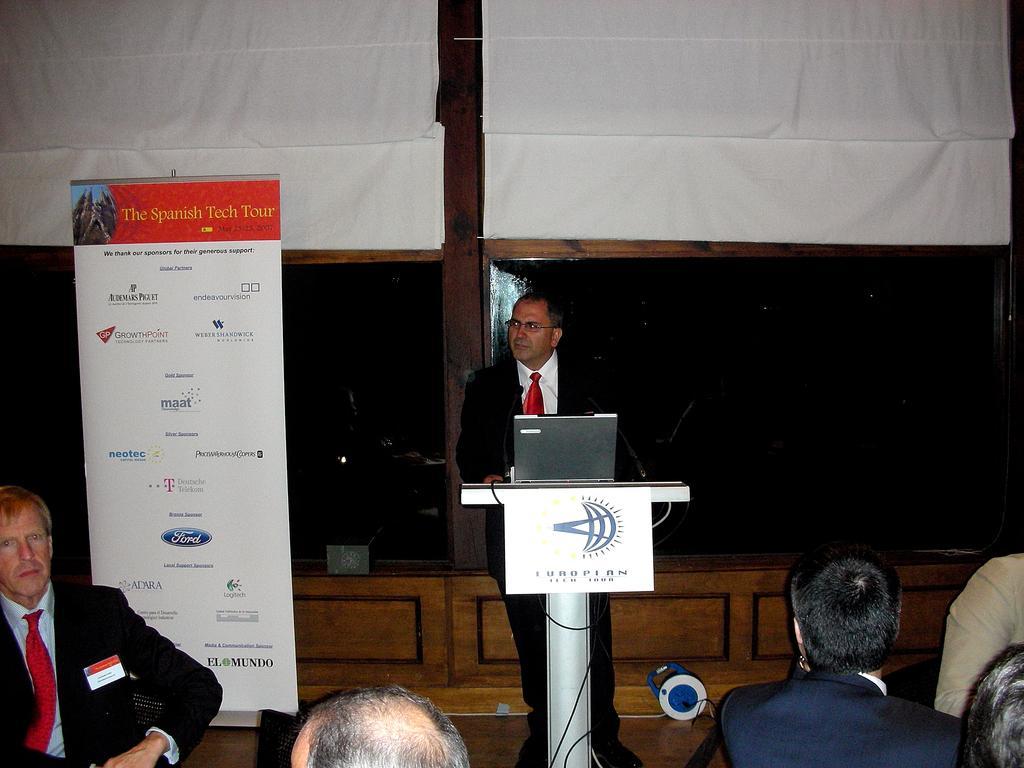Please provide a concise description of this image. This image consists of many persons. In the front, the man standing near the podium is wearing a black suit. In front of him, there is a podium on which a laptop is kept. On the left, the man sitting is wearing a black suit. Behind him, there is a banner. In the background, we can see two curtains and a wooden block. The curtains are in white color. 